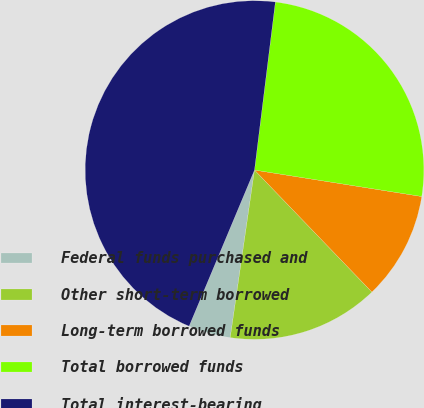Convert chart to OTSL. <chart><loc_0><loc_0><loc_500><loc_500><pie_chart><fcel>Federal funds purchased and<fcel>Other short-term borrowed<fcel>Long-term borrowed funds<fcel>Total borrowed funds<fcel>Total interest-bearing<nl><fcel>4.02%<fcel>14.48%<fcel>10.31%<fcel>25.53%<fcel>45.65%<nl></chart> 